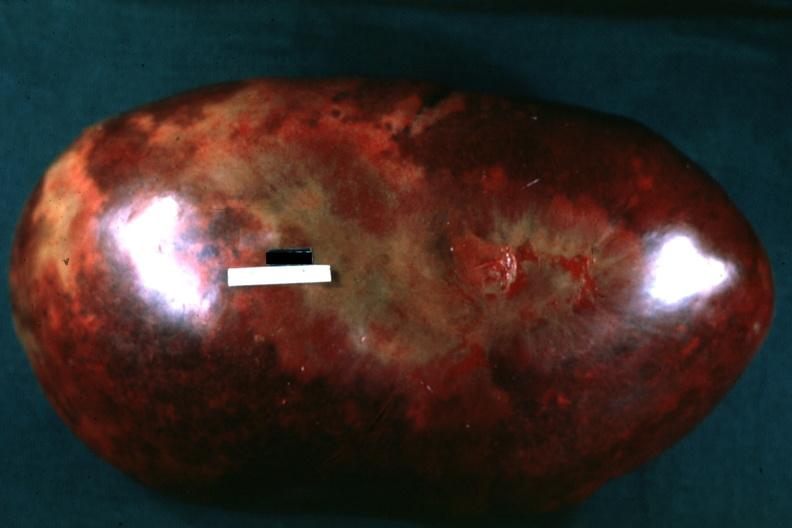does bone, calvarium show massively enlarged spleen with large infarcts seen from capsule?
Answer the question using a single word or phrase. No 